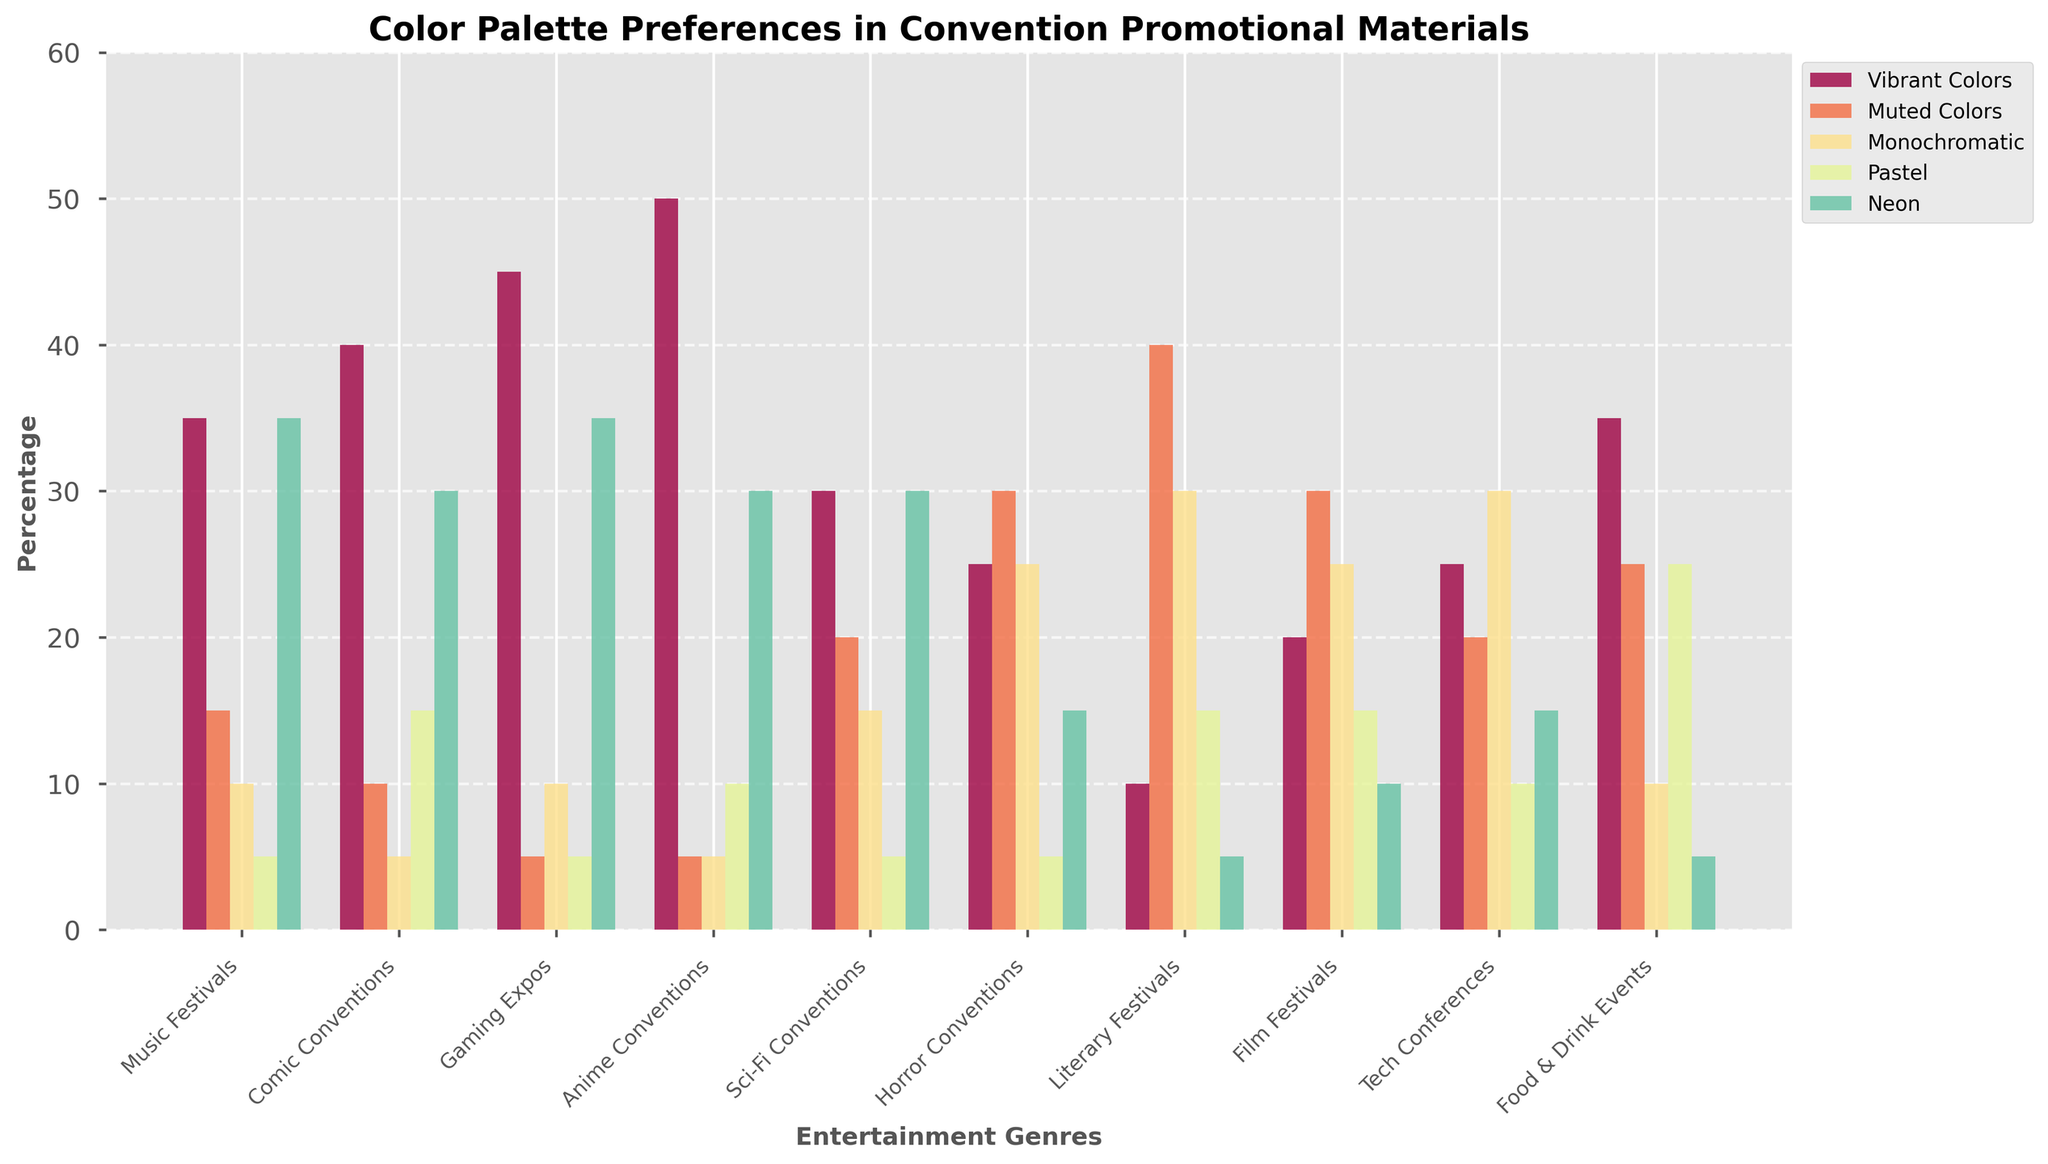What genre prefers Monochromatic colors the most? The genre with the highest percentage value for Monochromatic colors is the one that prefers it the most. By looking at the bars representing Monochromatic palettes, Horror Conventions have the highest value at 25%.
Answer: Horror Conventions Which color palette is most preferred overall across all genres? To find the most preferred color palette overall, sum the values of each color palette across all genres and compare totals. Vibrant Colors have the highest overall total, making it the most preferred.
Answer: Vibrant Colors How does the preference for Pastel colors in Literary Festivals compare to the preference for the same colors in Comic Conventions? Compare the heights of the bars representing Pastel colors for Literary Festivals and Comic Conventions. Literary Festivals have 15% and Comic Conventions have 15%, so they are equal.
Answer: Equal What is the difference in preference for Vibrant Colors between Gaming Expos and Music Festivals? Calculate the difference in heights of the Vibrant Colors bars for Gaming Expos and Music Festivals. Gaming Expos have 45% while Music Festivals have 35%. Thus, 45% - 35% = 10%.
Answer: 10% Which genres prefer Neon colors over Muted Colors but not Monochromatic colors? Identify genres where the bar for Neon colors is higher than the one for Muted Colors, but the bar for Monochromatic is either lower or equal to both Neon and Muted Colors. Music Festivals (35% Neon, 15% Muted, 10% Monochromatic), Gaming Expos (35% Neon, 5% Muted, 10% Monochromatic), and Anime Conventions (30% Neon, 5% Muted, 5% Monochromatic) meet these criteria.
Answer: Music Festivals, Gaming Expos, Anime Conventions What is the sum of preferences for all color palettes in Sci-Fi Conventions? Add the percentage values of all color palettes in Sci-Fi Conventions. 30 (Vibrant) + 20 (Muted) + 15 (Monochromatic) + 5 (Pastel) + 30 (Neon) = 100.
Answer: 100% Which genre has the least preference for Neon colors? The genre with the shortest bar for Neon colors has the least preference. Literary Festivals prefer Neon colors the least at 5%.
Answer: Literary Festivals How does the preference for Muted colors in Food & Drink Events compare to that in Tech Conferences? Compare the bar heights for Muted colors in Food & Drink Events and Tech Conferences. Food & Drink Events have 25% and Tech Conferences have 20%, so Food & Drink Events have a higher preference.
Answer: Food & Drink Events Which genre shows equal preference for Muted and Monochromatic colors? Look for genres where the bars for Muted and Monochromatic colors have equal heights. Tech Conferences show equal preference for both at 30%.
Answer: Tech Conferences 